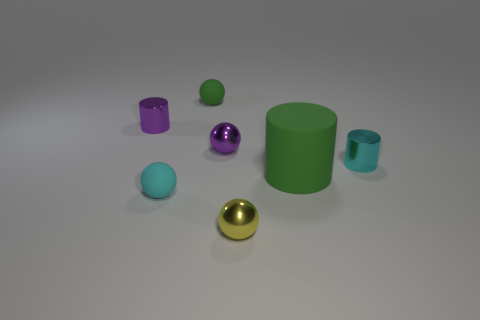Is the number of tiny metallic balls that are in front of the big green cylinder less than the number of small cyan cylinders that are to the right of the tiny green matte thing? Upon examining the image, I see one tiny metallic ball in front of the big green cylinder and one small cyan cylinder to the right of the tiny green matte object. Therefore, the number of tiny metallic balls in front of the big green cylinder is equal to the number of small cyan cylinders to the right of the tiny green matte thing, not less. Hence, both quantities are the same, with one item each. 